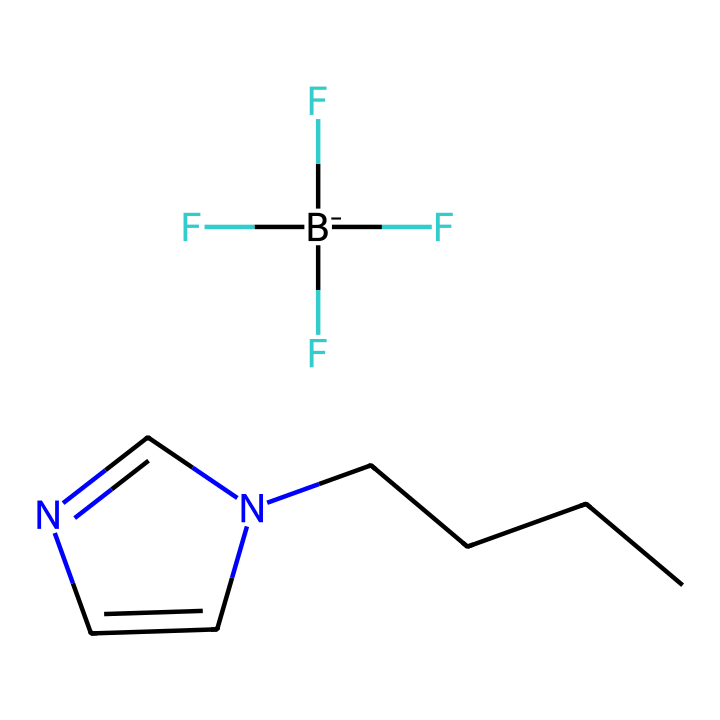What is the main functional group present in this ionic liquid? The chemical structure includes a nitrogen atom within a cyclic structure (C=N), indicative of an imine functional group. This nitrogen also suggests the presence of a quaternary ammonium if we consider its roles in ionic liquids.
Answer: imine How many carbon atoms are present in the structure? By counting the carbon atoms in the provided SMILES, there are six carbon atoms (five in the chain and one in the cyclic structure).
Answer: six What type of ionic liquid is represented by this chemical? The structure contains a quaternary ammonium (due to the nitrogen bonded to carbon atoms without any hydrogen) in combination with a fluorinated anion (as indicated by the presence of [B-](F)(F)F). Therefore, this structure is a fluorinated quaternary ammonium ionic liquid.
Answer: fluorinated quaternary ammonium How many different types of atoms are present in the ionic liquid? From the structure, we see carbon (C), nitrogen (N), fluorine (F), and boron (B), totaling four distinct types of atoms.
Answer: four Is this ionic liquid likely to have low volatility? Ionic liquids typically have very low volatility due to their strong ionic interactions and the absence of a significant vapor pressure, which is suggested by the presence of a quaternary ammonium structure and a stable anion like fluoroborate.
Answer: yes What characteristic of this ionic liquid makes it suitable for cleaning applications? The presence of the fluorinated anion and the ionic nature of this liquid allows it to dissolve a variety of polar and non-polar substances, contributing to its effectiveness as a cleaning agent.
Answer: dissolving properties 